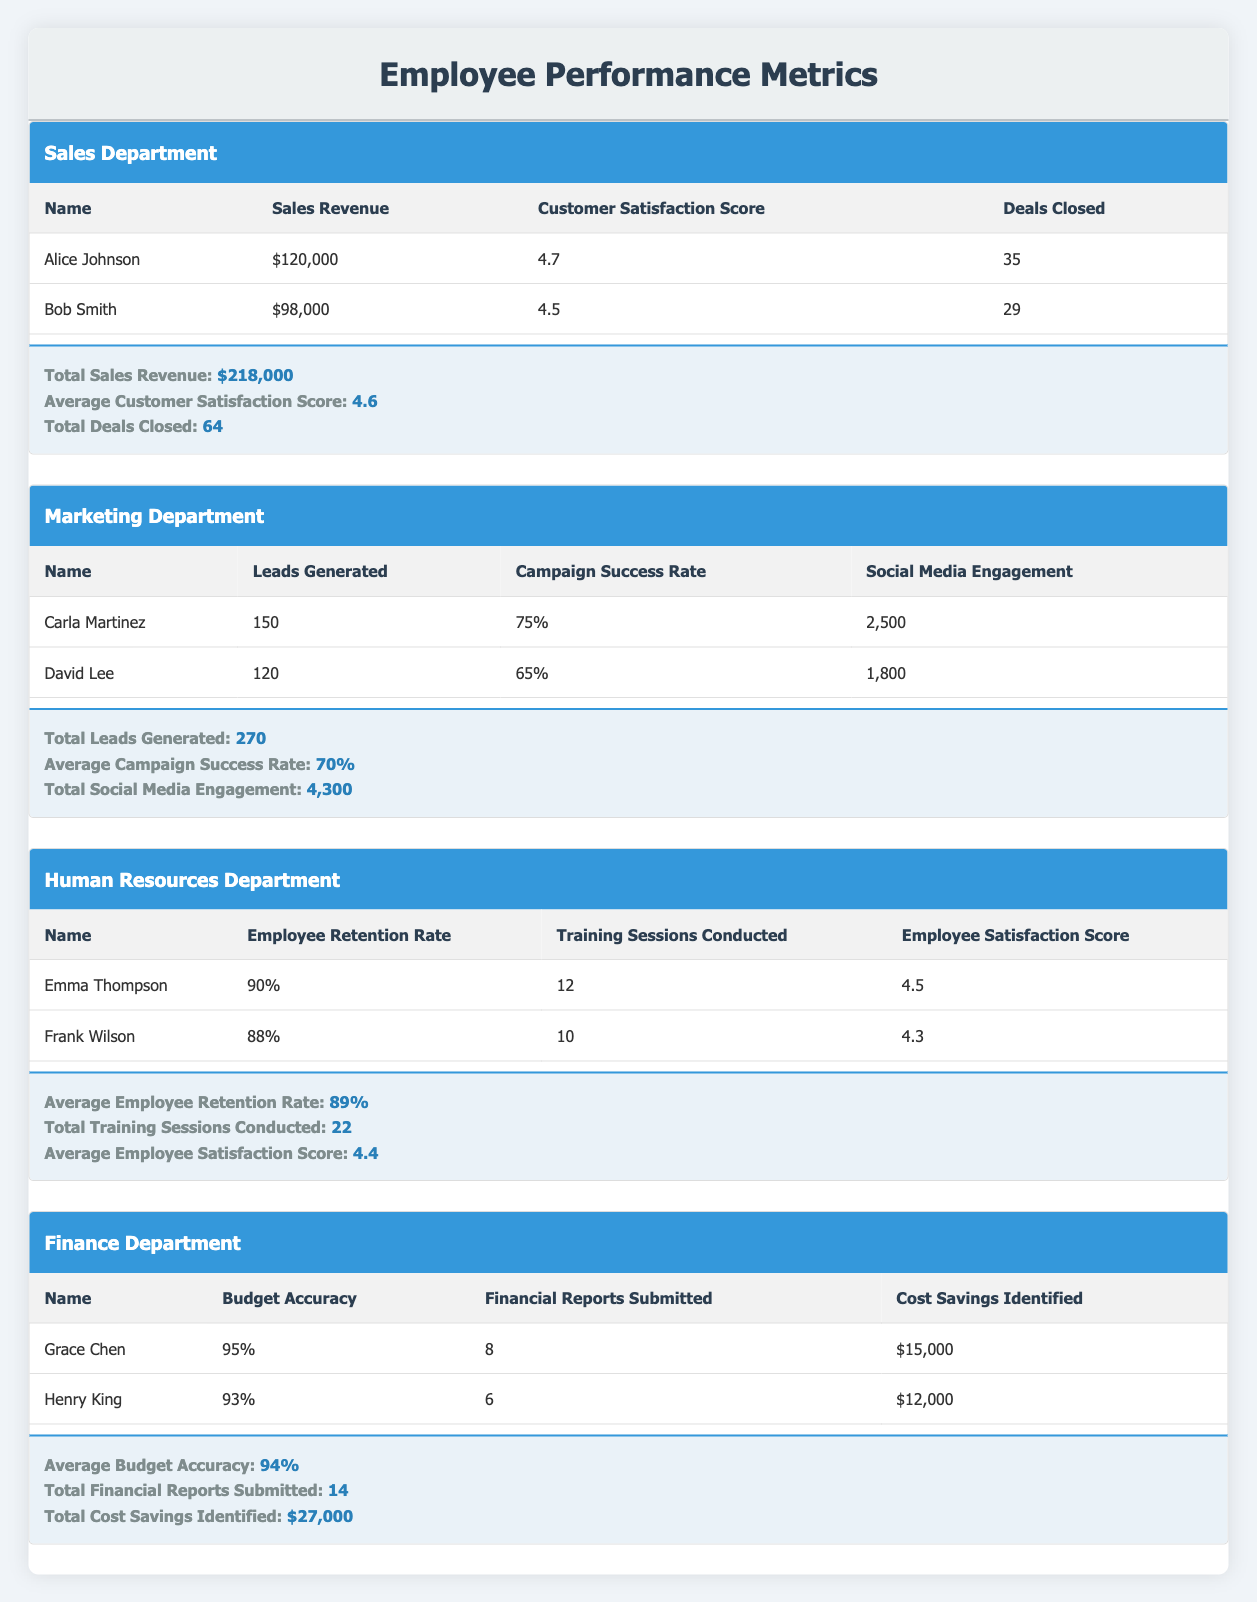What is the total sales revenue generated by the Sales department? The Sales department's Total Sales Revenue is provided in the Department Metrics section and is directly listed as $218,000.
Answer: $218,000 Who achieved a higher customer satisfaction score, Alice Johnson or Bob Smith? Alice Johnson has a Customer Satisfaction Score of 4.7, while Bob Smith has a score of 4.5. Therefore, Alice Johnson achieved a higher score.
Answer: Alice Johnson What is the average employee satisfaction score for the Human Resources department? The average employee satisfaction score is listed in the Department Metrics section as 4.4.
Answer: 4.4 How many training sessions were conducted by both Emma Thompson and Frank Wilson? Emma Thompson conducted 12 training sessions and Frank Wilson conducted 10 training sessions. The total is 12 + 10 = 22.
Answer: 22 Is the budget accuracy of Grace Chen higher than that of Henry King? Grace Chen has a Budget Accuracy of 95%, while Henry King has 93%. Since 95% is greater than 93%, the statement is true.
Answer: Yes What is the total cost savings identified by the Finance department’s employees? Grace Chen identified $15,000 in cost savings, and Henry King identified $12,000. The total savings are $15,000 + $12,000 = $27,000.
Answer: $27,000 Which employee generated the most leads in the Marketing department? Carla Martinez generated 150 leads, while David Lee generated 120 leads. Since 150 is higher than 120, Carla Martinez generated the most leads.
Answer: Carla Martinez What is the average campaign success rate for the Marketing department? The average campaign success rate is found in the Department Metrics section and is listed as 70%, which is the overall average of both employees' rates.
Answer: 70% If we compare the average customer satisfaction score in the Sales department with the average employee satisfaction score in Human Resources, which one is higher? The average customer satisfaction score in the Sales department is 4.6, while the average employee satisfaction score in Human Resources is 4.4. Since 4.6 is greater than 4.4, the customer satisfaction score is higher.
Answer: Sales department 